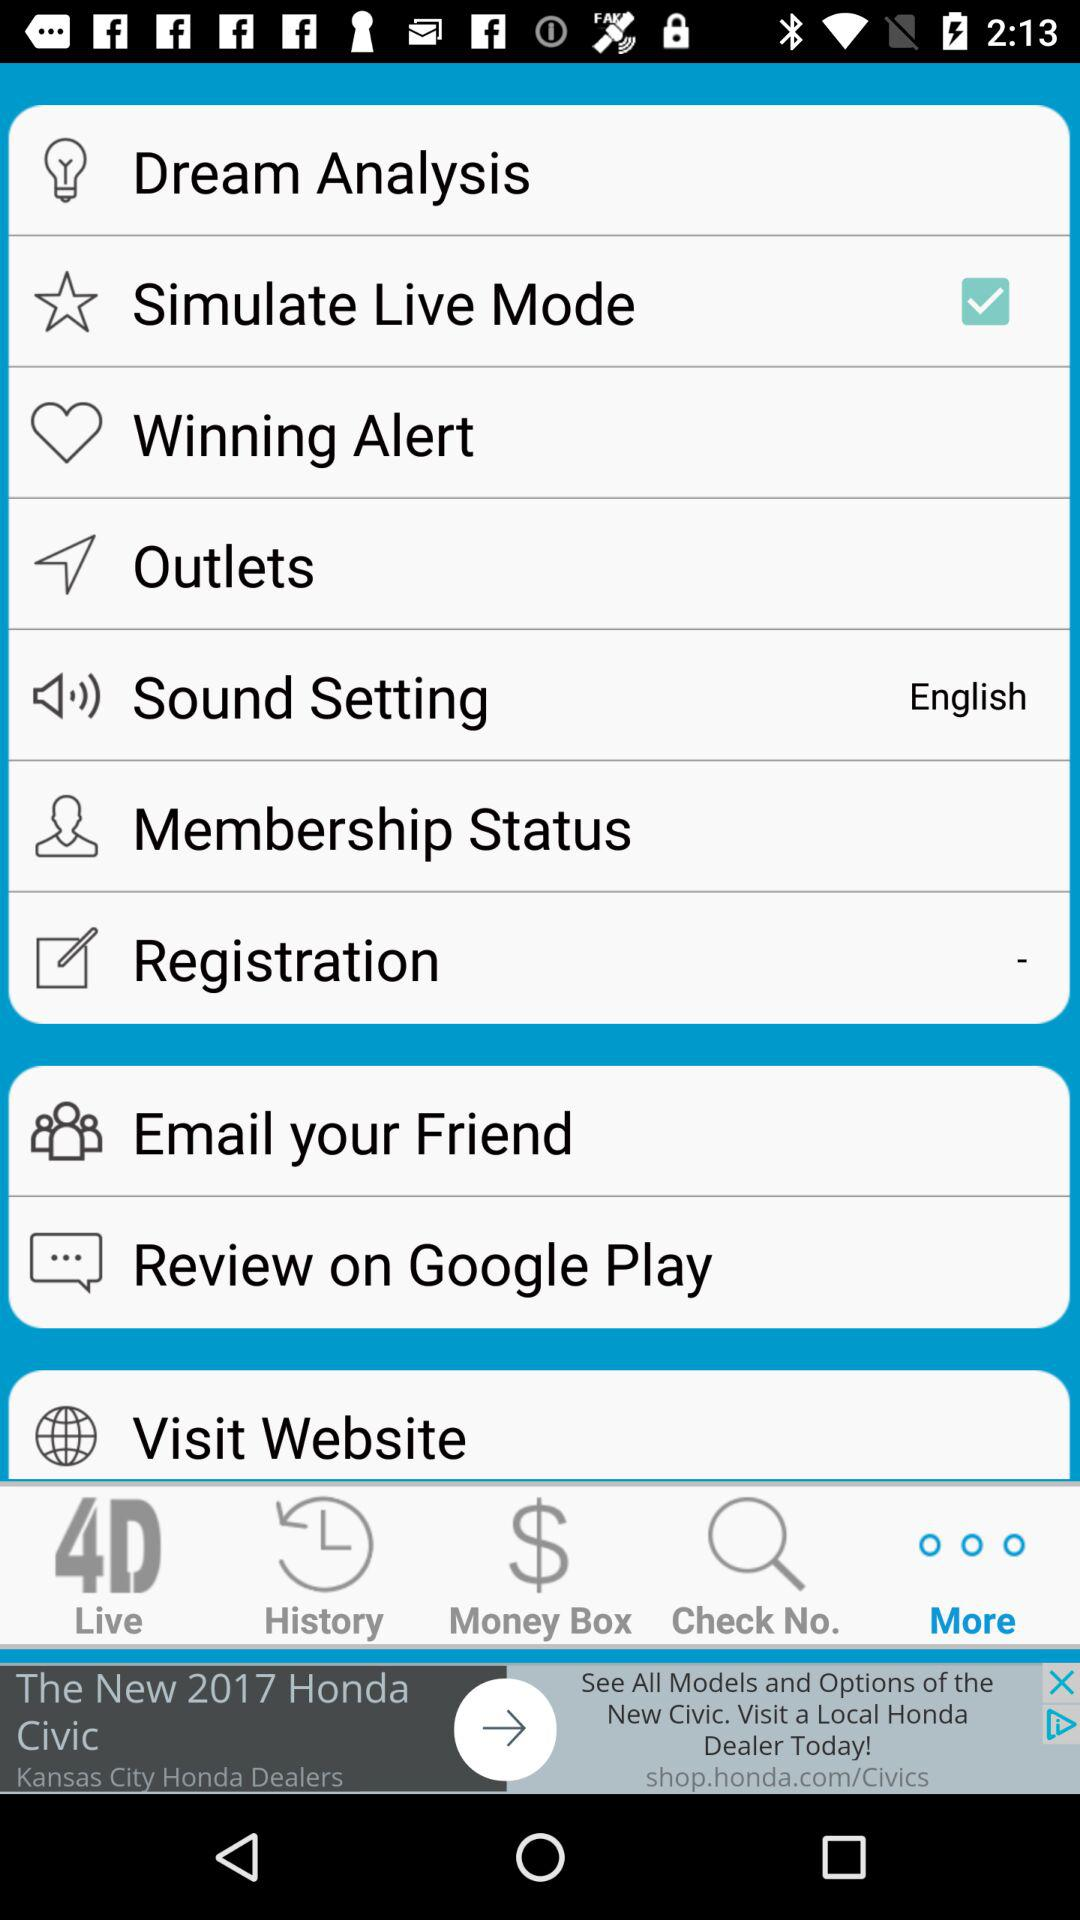Which option is selected? The selected option is "More". 